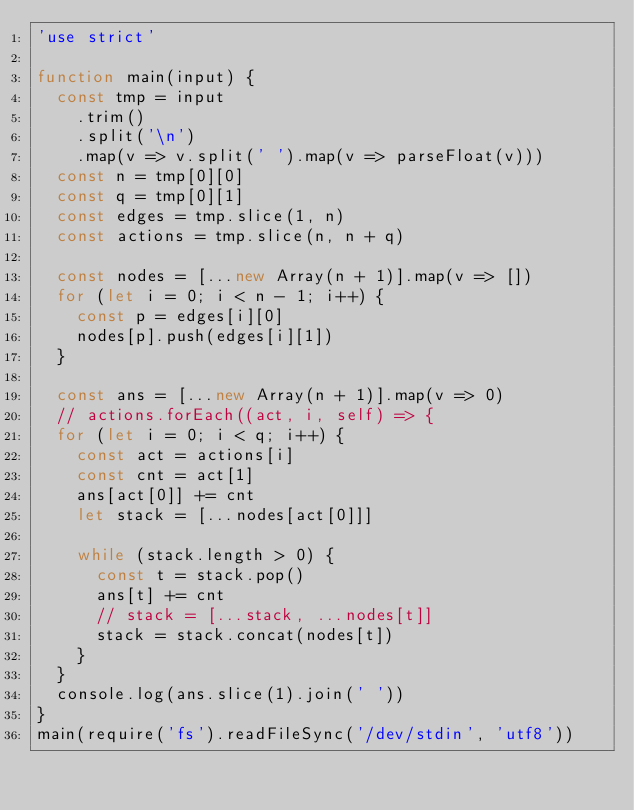Convert code to text. <code><loc_0><loc_0><loc_500><loc_500><_JavaScript_>'use strict'

function main(input) {
  const tmp = input
    .trim()
    .split('\n')
    .map(v => v.split(' ').map(v => parseFloat(v)))
  const n = tmp[0][0]
  const q = tmp[0][1]
  const edges = tmp.slice(1, n)
  const actions = tmp.slice(n, n + q)

  const nodes = [...new Array(n + 1)].map(v => [])
  for (let i = 0; i < n - 1; i++) {
    const p = edges[i][0]
    nodes[p].push(edges[i][1])
  }

  const ans = [...new Array(n + 1)].map(v => 0)
  // actions.forEach((act, i, self) => {
  for (let i = 0; i < q; i++) {
    const act = actions[i]
    const cnt = act[1]
    ans[act[0]] += cnt
    let stack = [...nodes[act[0]]]

    while (stack.length > 0) {
      const t = stack.pop()
      ans[t] += cnt
      // stack = [...stack, ...nodes[t]]
      stack = stack.concat(nodes[t])
    }
  }
  console.log(ans.slice(1).join(' '))
}
main(require('fs').readFileSync('/dev/stdin', 'utf8'))
</code> 